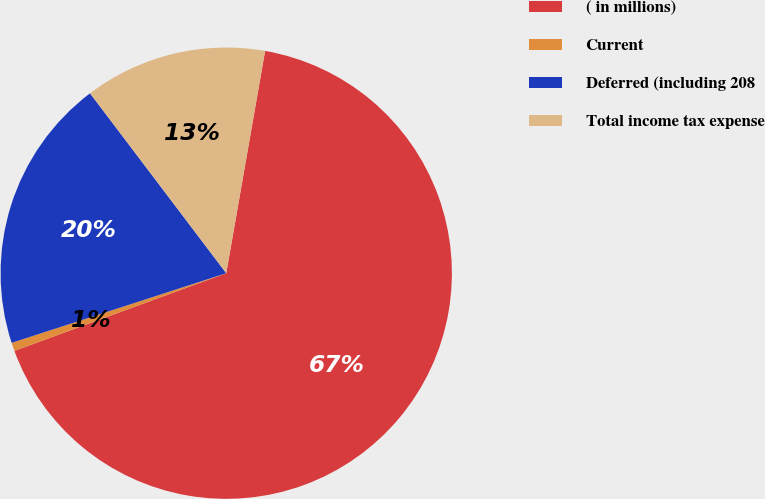Convert chart. <chart><loc_0><loc_0><loc_500><loc_500><pie_chart><fcel>( in millions)<fcel>Current<fcel>Deferred (including 208<fcel>Total income tax expense<nl><fcel>66.65%<fcel>0.6%<fcel>19.68%<fcel>13.07%<nl></chart> 